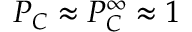<formula> <loc_0><loc_0><loc_500><loc_500>P _ { C } \approx P _ { C } ^ { \infty } \approx 1</formula> 